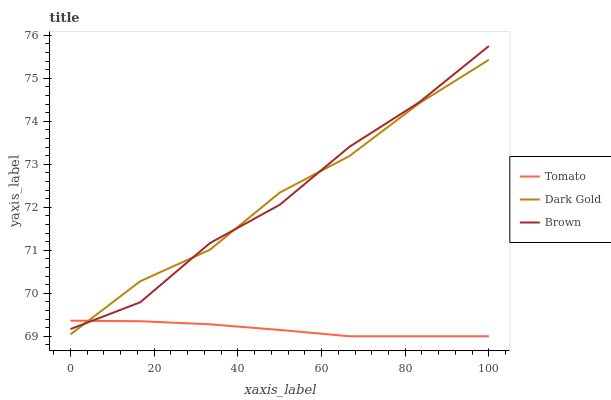Does Tomato have the minimum area under the curve?
Answer yes or no. Yes. Does Dark Gold have the maximum area under the curve?
Answer yes or no. Yes. Does Brown have the minimum area under the curve?
Answer yes or no. No. Does Brown have the maximum area under the curve?
Answer yes or no. No. Is Tomato the smoothest?
Answer yes or no. Yes. Is Brown the roughest?
Answer yes or no. Yes. Is Dark Gold the smoothest?
Answer yes or no. No. Is Dark Gold the roughest?
Answer yes or no. No. Does Dark Gold have the lowest value?
Answer yes or no. No. Does Brown have the highest value?
Answer yes or no. Yes. Does Dark Gold have the highest value?
Answer yes or no. No. 